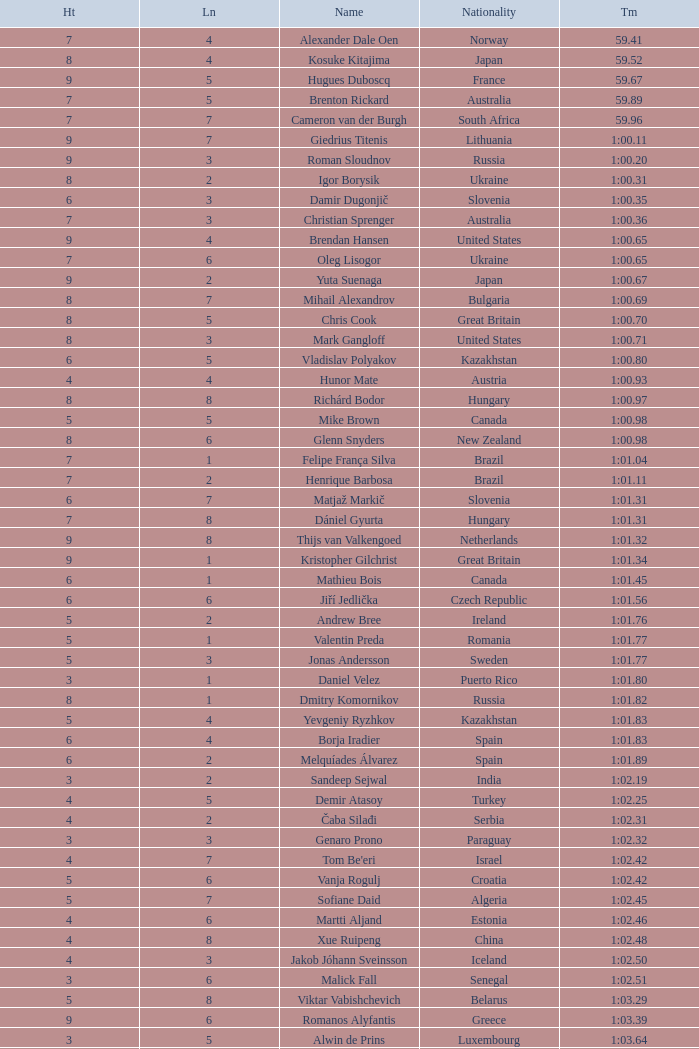What is the smallest lane number of Xue Ruipeng? 8.0. 